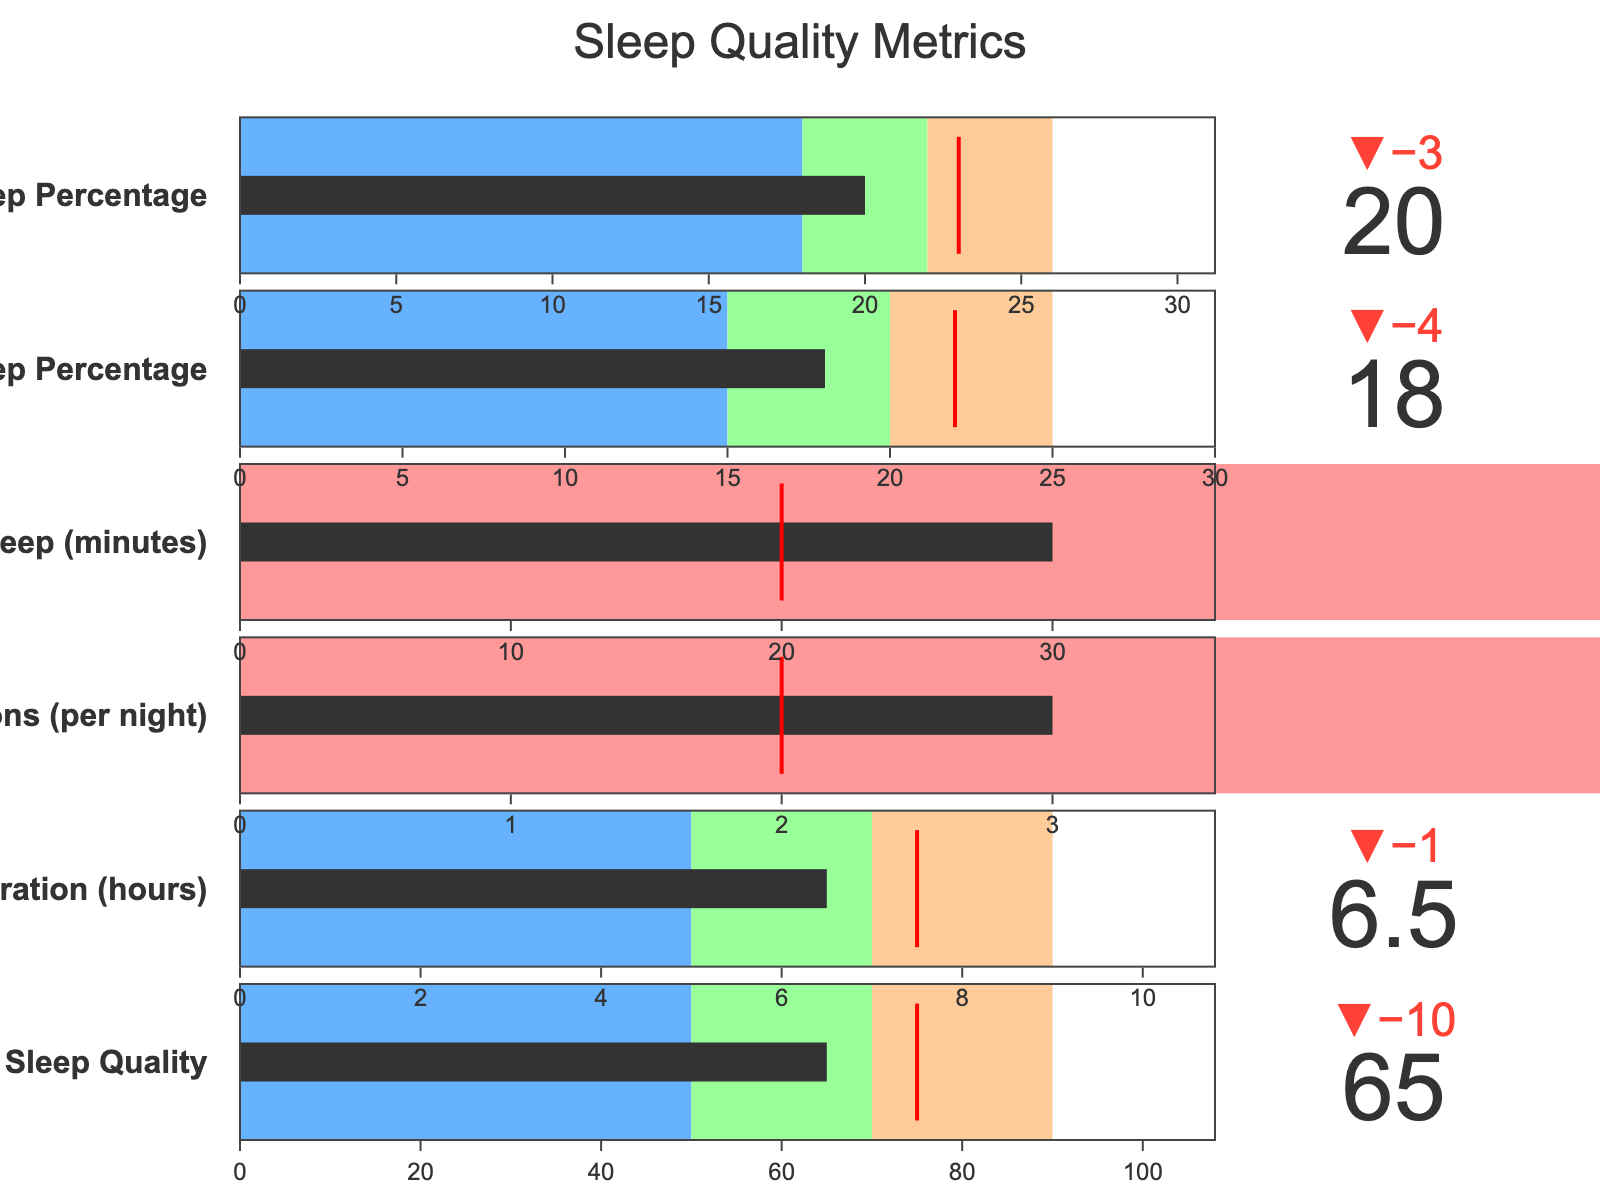What's the overall sleep quality score compared to the benchmark? The actual overall sleep quality score is 65, while the benchmark score is 75, as shown in the figure.
Answer: 65 vs 75 How does the actual sleep duration compare to the benchmark? The actual sleep duration is 6.5 hours, and the benchmark duration is 7.5 hours, as displayed in the figure.
Answer: 6.5 hours vs 7.5 hours Which sleep metric has the closest actual value to its benchmark? Compare the differences between the actual values and benchmarks for all metrics. The smallest difference can be observed between the actual REM Sleep Percentage (20%) and its benchmark (23%), with a difference of 3%.
Answer: REM Sleep Percentage In which category does the sleep interruptions metric fall in terms of quality? The actual sleep interruptions value is 3 per night. On the gauge, it falls in the range of 2 to 4, which is marked as "Fair."
Answer: Fair What's the difference between the actual and benchmark time to fall asleep? The actual time to fall asleep is 30 minutes and the benchmark is 20 minutes. Subtract the benchmark from the actual: 30 - 20 = 10 minutes.
Answer: 10 minutes How does the actual deep sleep percentage compare with the "Good" threshold? The actual deep sleep percentage is 18%, and the "Good" threshold is marked at 20%. The actual percentage is below the "Good" category.
Answer: Below Which sleep metric is performing the best relative to its benchmark? Examine all the metrics. The closest to the benchmark is the REM Sleep Percentage (actual: 20%, benchmark: 23%). The delta indicator shows the smallest difference.
Answer: REM Sleep Percentage How many hours below the benchmark is the actual sleep duration? The benchmark sleep duration is 7.5 hours, and the actual duration is 6.5 hours. The difference is 7.5 - 6.5 = 1 hour.
Answer: 1 hour What can be inferred about the overall sleep quality based on its color-coded segments? The overall sleep quality score is 65, which falls in the "Fair" category, indicated by color-coding in the figure.
Answer: Fair How many metrics fall into the "Poor" quality category? Check the range segments for each metric. The "Poor" category is indicated from 0 up to the "Fair" threshold. No actual values fall within the "Poor" category range.
Answer: 0 